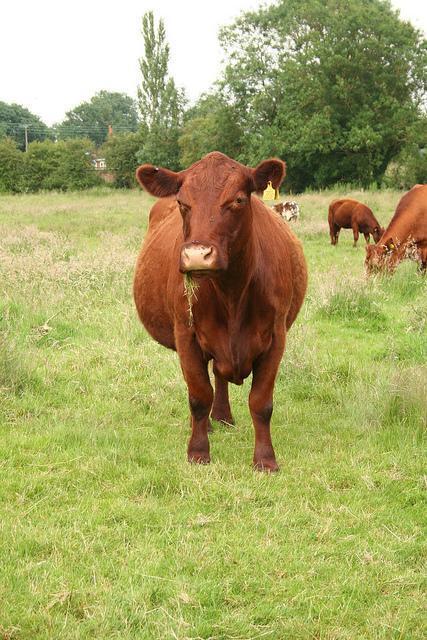How many cows are there?
Give a very brief answer. 2. How many people are dressed in green?
Give a very brief answer. 0. 